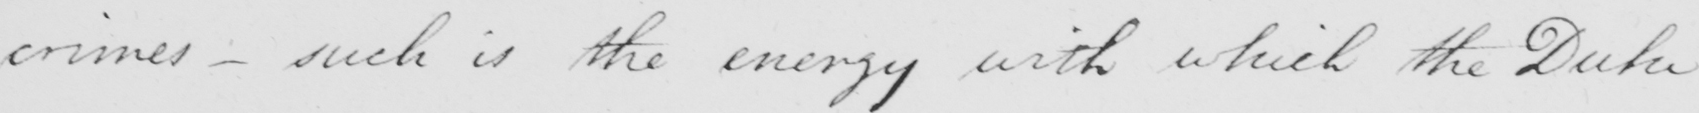Please provide the text content of this handwritten line. crimes - such is the energy with which the Duke 